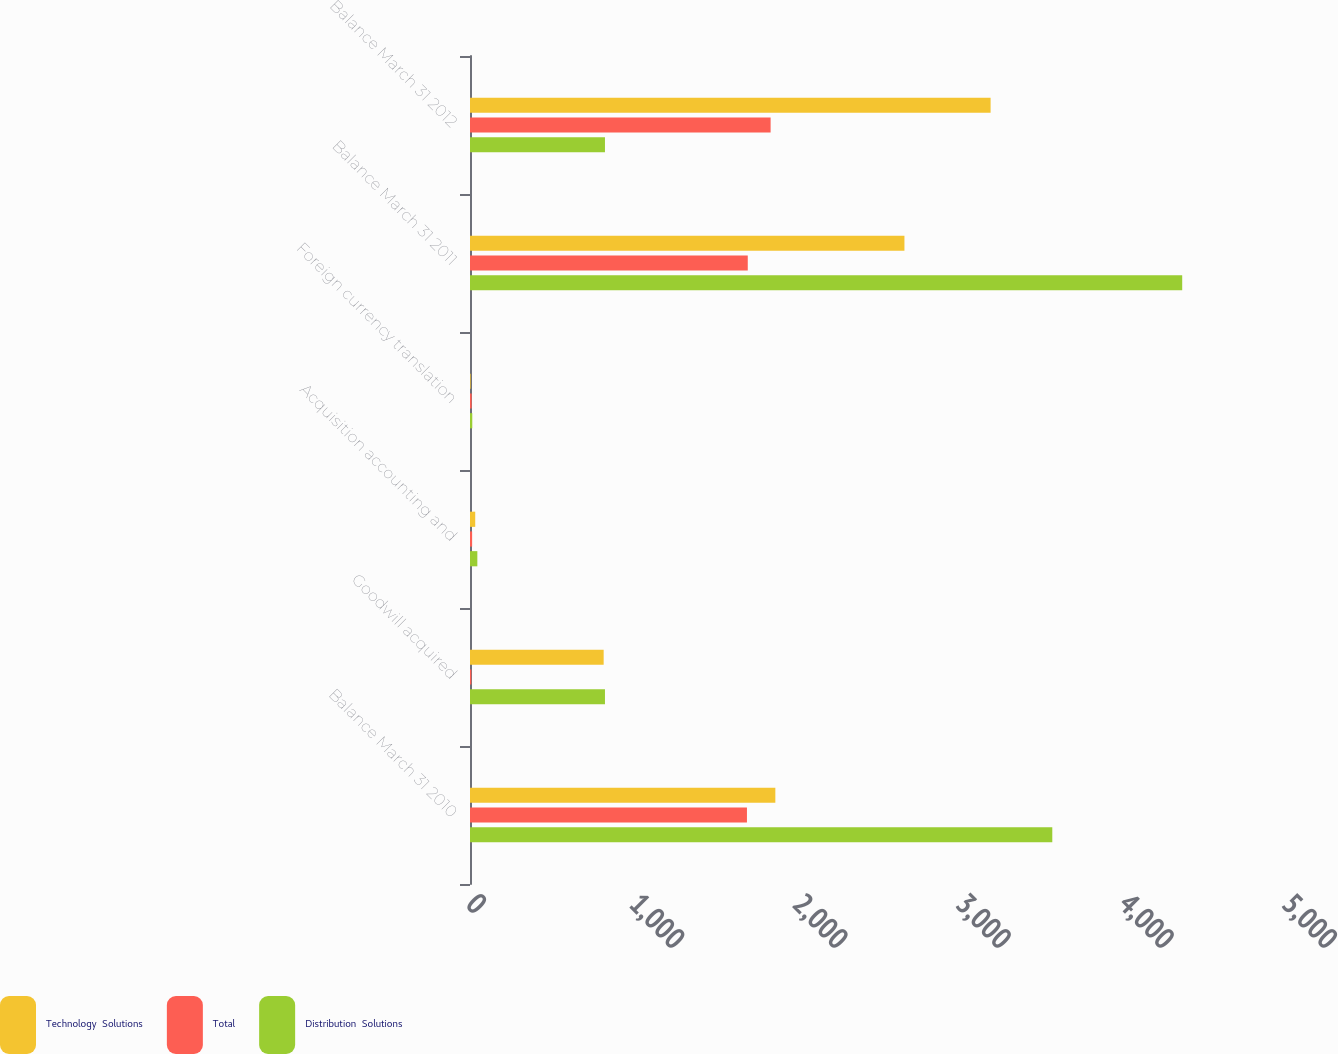Convert chart to OTSL. <chart><loc_0><loc_0><loc_500><loc_500><stacked_bar_chart><ecel><fcel>Balance March 31 2010<fcel>Goodwill acquired<fcel>Acquisition accounting and<fcel>Foreign currency translation<fcel>Balance March 31 2011<fcel>Balance March 31 2012<nl><fcel>Technology  Solutions<fcel>1871<fcel>819<fcel>32<fcel>4<fcel>2662<fcel>3190<nl><fcel>Total<fcel>1697<fcel>8<fcel>13<fcel>10<fcel>1702<fcel>1842<nl><fcel>Distribution  Solutions<fcel>3568<fcel>827<fcel>45<fcel>14<fcel>4364<fcel>827<nl></chart> 